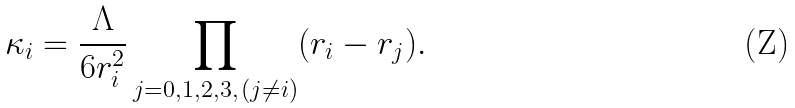<formula> <loc_0><loc_0><loc_500><loc_500>\kappa _ { i } = \frac { \Lambda } { 6 r _ { i } ^ { 2 } } \prod _ { j = 0 , 1 , 2 , 3 , \, ( j \neq i ) } ( r _ { i } - r _ { j } ) .</formula> 